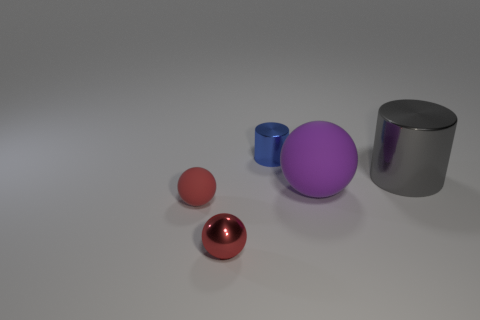Subtract all gray blocks. How many red balls are left? 2 Subtract all rubber spheres. How many spheres are left? 1 Add 4 gray cylinders. How many objects exist? 9 Subtract all spheres. How many objects are left? 2 Subtract all gray balls. Subtract all gray cylinders. How many balls are left? 3 Add 1 big shiny cylinders. How many big shiny cylinders are left? 2 Add 2 tiny shiny balls. How many tiny shiny balls exist? 3 Subtract 0 green cubes. How many objects are left? 5 Subtract all small purple spheres. Subtract all tiny objects. How many objects are left? 2 